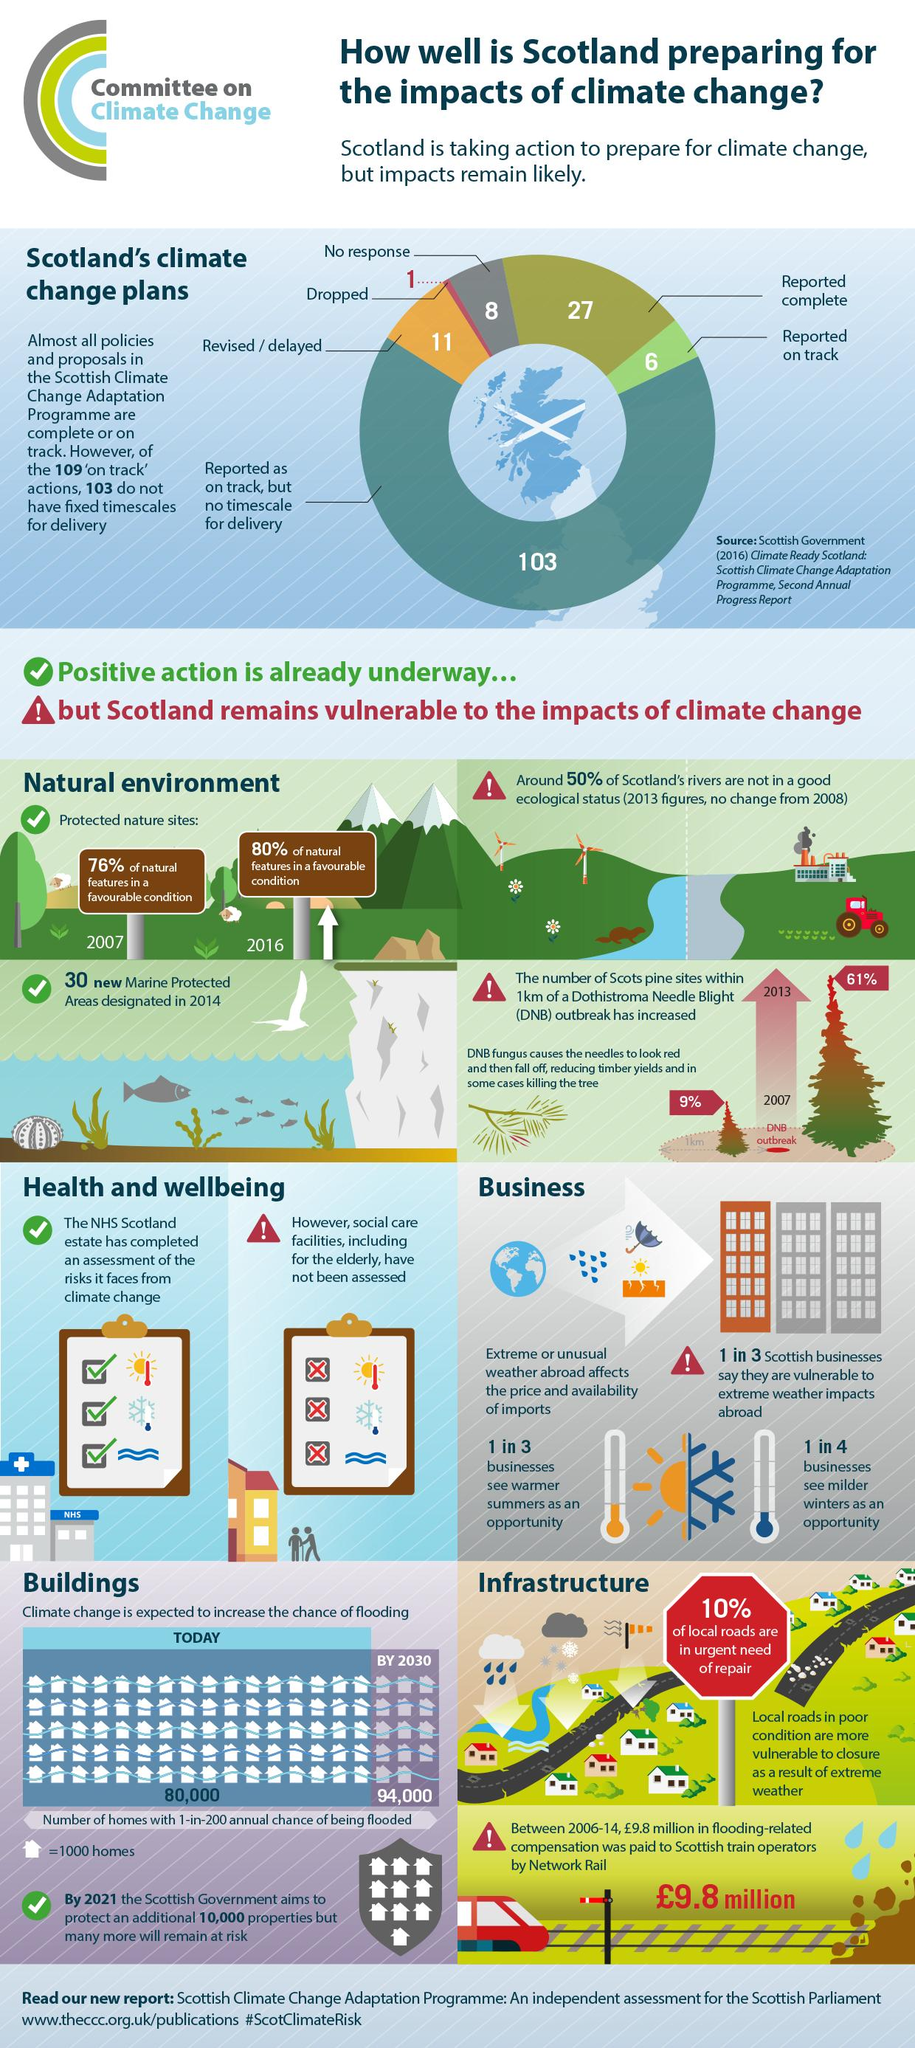Draw attention to some important aspects in this diagram. The percentage of natural features found in favourable conditions increased by 4% from 2007 to 2016. According to a recent survey, 33.33% of businesses view warmer summers as an opportunity. As of the most recent data available, 27 of the policies and proposals outlined in the Scottish climate change adaptation program have been reported as complete. From 2007 to 2016, there was a 52% increase in the outbreak of Dengue Nuevo B (DNB) in Colombia. Twenty-five percent of businesses view milder winters as an opportunity, according to a recent survey. 